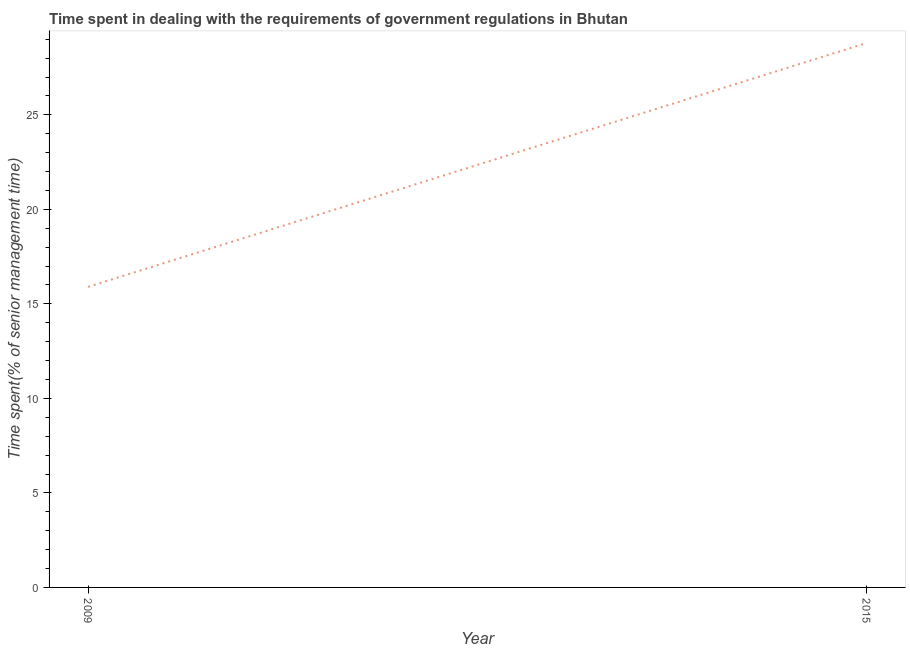What is the time spent in dealing with government regulations in 2015?
Provide a short and direct response. 28.8. Across all years, what is the maximum time spent in dealing with government regulations?
Give a very brief answer. 28.8. Across all years, what is the minimum time spent in dealing with government regulations?
Provide a short and direct response. 15.9. In which year was the time spent in dealing with government regulations maximum?
Make the answer very short. 2015. In which year was the time spent in dealing with government regulations minimum?
Ensure brevity in your answer.  2009. What is the sum of the time spent in dealing with government regulations?
Keep it short and to the point. 44.7. What is the average time spent in dealing with government regulations per year?
Your answer should be very brief. 22.35. What is the median time spent in dealing with government regulations?
Give a very brief answer. 22.35. In how many years, is the time spent in dealing with government regulations greater than 11 %?
Your answer should be very brief. 2. What is the ratio of the time spent in dealing with government regulations in 2009 to that in 2015?
Provide a succinct answer. 0.55. How many years are there in the graph?
Keep it short and to the point. 2. What is the title of the graph?
Keep it short and to the point. Time spent in dealing with the requirements of government regulations in Bhutan. What is the label or title of the Y-axis?
Provide a succinct answer. Time spent(% of senior management time). What is the Time spent(% of senior management time) of 2015?
Make the answer very short. 28.8. What is the difference between the Time spent(% of senior management time) in 2009 and 2015?
Your response must be concise. -12.9. What is the ratio of the Time spent(% of senior management time) in 2009 to that in 2015?
Keep it short and to the point. 0.55. 